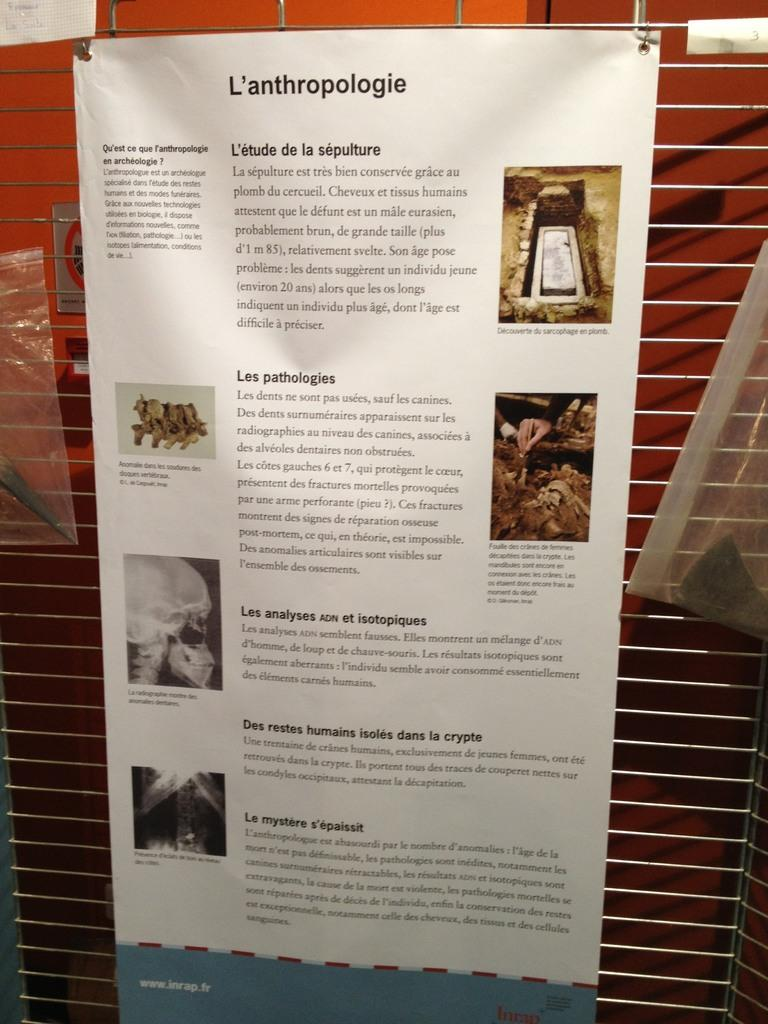What is present on the paper in the image? There is a skull depicted on the paper. What can be seen in the background of the image? There is a wall in the background of the image. Whose hand is visible in the image? A person's hand is visible in the image. What type of cherry is being held by the person in the image? There is no cherry present in the image; only a paper with a skull and a person's hand are visible. 